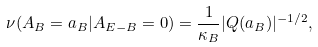Convert formula to latex. <formula><loc_0><loc_0><loc_500><loc_500>\nu ( A _ { B } = a _ { B } | A _ { E - B } = 0 ) = \frac { 1 } { \kappa _ { B } } | Q ( a _ { B } ) | ^ { - 1 / 2 } ,</formula> 